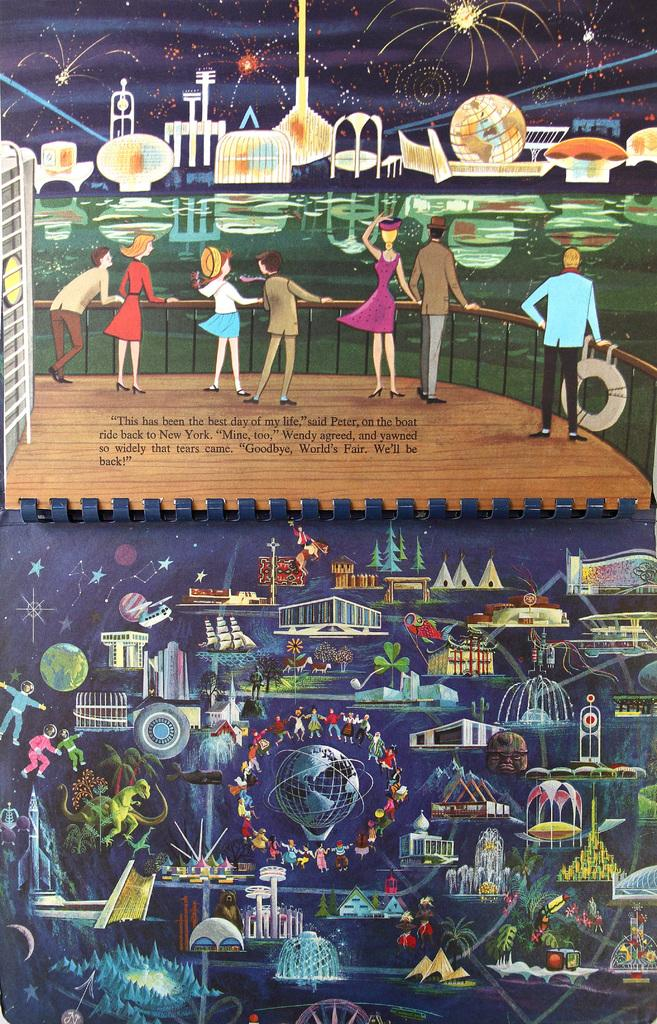<image>
Describe the image concisely. Poster showing many people partying watching fireworks in New York. 